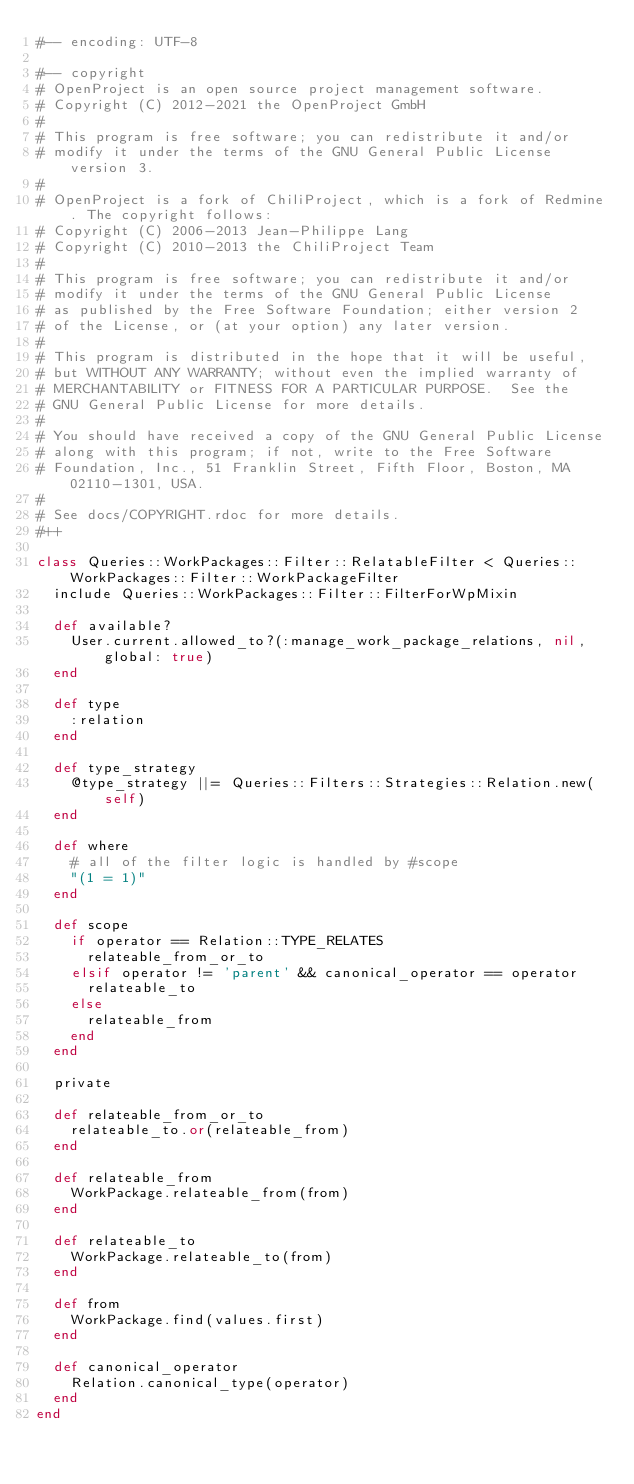<code> <loc_0><loc_0><loc_500><loc_500><_Ruby_>#-- encoding: UTF-8

#-- copyright
# OpenProject is an open source project management software.
# Copyright (C) 2012-2021 the OpenProject GmbH
#
# This program is free software; you can redistribute it and/or
# modify it under the terms of the GNU General Public License version 3.
#
# OpenProject is a fork of ChiliProject, which is a fork of Redmine. The copyright follows:
# Copyright (C) 2006-2013 Jean-Philippe Lang
# Copyright (C) 2010-2013 the ChiliProject Team
#
# This program is free software; you can redistribute it and/or
# modify it under the terms of the GNU General Public License
# as published by the Free Software Foundation; either version 2
# of the License, or (at your option) any later version.
#
# This program is distributed in the hope that it will be useful,
# but WITHOUT ANY WARRANTY; without even the implied warranty of
# MERCHANTABILITY or FITNESS FOR A PARTICULAR PURPOSE.  See the
# GNU General Public License for more details.
#
# You should have received a copy of the GNU General Public License
# along with this program; if not, write to the Free Software
# Foundation, Inc., 51 Franklin Street, Fifth Floor, Boston, MA  02110-1301, USA.
#
# See docs/COPYRIGHT.rdoc for more details.
#++

class Queries::WorkPackages::Filter::RelatableFilter < Queries::WorkPackages::Filter::WorkPackageFilter
  include Queries::WorkPackages::Filter::FilterForWpMixin

  def available?
    User.current.allowed_to?(:manage_work_package_relations, nil, global: true)
  end

  def type
    :relation
  end

  def type_strategy
    @type_strategy ||= Queries::Filters::Strategies::Relation.new(self)
  end

  def where
    # all of the filter logic is handled by #scope
    "(1 = 1)"
  end

  def scope
    if operator == Relation::TYPE_RELATES
      relateable_from_or_to
    elsif operator != 'parent' && canonical_operator == operator
      relateable_to
    else
      relateable_from
    end
  end

  private

  def relateable_from_or_to
    relateable_to.or(relateable_from)
  end

  def relateable_from
    WorkPackage.relateable_from(from)
  end

  def relateable_to
    WorkPackage.relateable_to(from)
  end

  def from
    WorkPackage.find(values.first)
  end

  def canonical_operator
    Relation.canonical_type(operator)
  end
end
</code> 